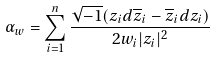<formula> <loc_0><loc_0><loc_500><loc_500>\alpha _ { w } = \sum _ { i = 1 } ^ { n } \frac { \sqrt { - 1 } ( z _ { i } d \overline { z } _ { i } - \overline { z } _ { i } d z _ { i } ) } { 2 w _ { i } | z _ { i } | ^ { 2 } }</formula> 